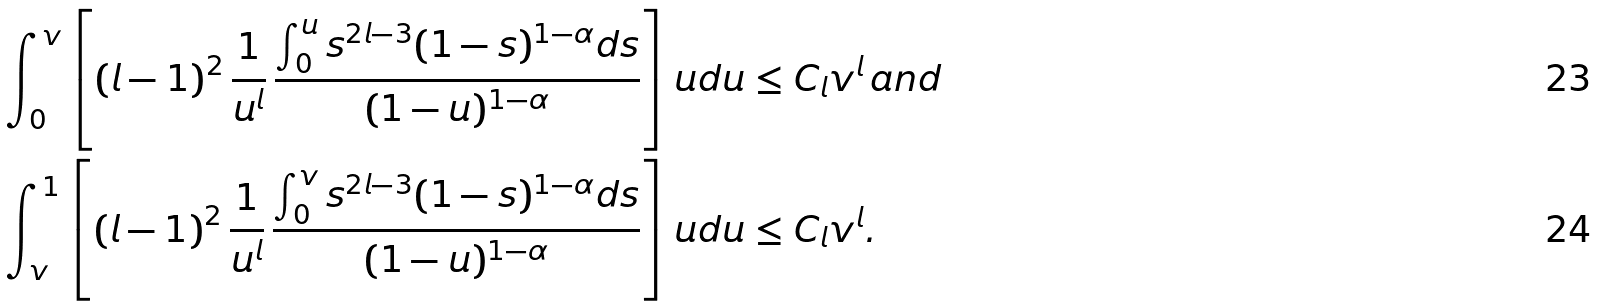Convert formula to latex. <formula><loc_0><loc_0><loc_500><loc_500>\int _ { 0 } ^ { v } \left [ \left ( l - 1 \right ) ^ { 2 } \frac { 1 } { u ^ { l } } \, \frac { \int _ { 0 } ^ { u } s ^ { 2 l - 3 } ( 1 - s ) ^ { 1 - \alpha } d s } { ( 1 - u ) ^ { 1 - \alpha } } \right ] u d u & \leq C _ { l } v ^ { l } \, a n d \\ \int _ { v } ^ { 1 } \left [ \left ( l - 1 \right ) ^ { 2 } \frac { 1 } { u ^ { l } } \, \frac { \int _ { 0 } ^ { v } s ^ { 2 l - 3 } ( 1 - s ) ^ { 1 - \alpha } d s } { ( 1 - u ) ^ { 1 - \alpha } } \right ] u d u & \leq C _ { l } v ^ { l } .</formula> 